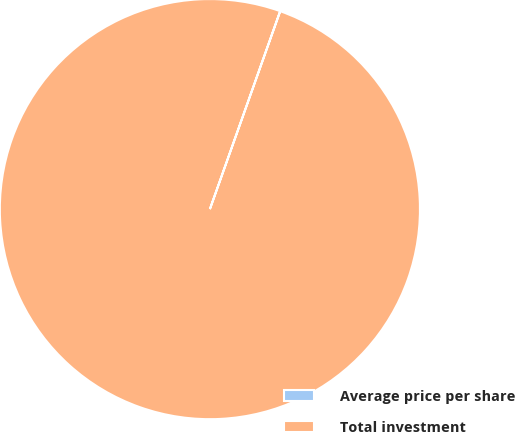<chart> <loc_0><loc_0><loc_500><loc_500><pie_chart><fcel>Average price per share<fcel>Total investment<nl><fcel>0.01%<fcel>99.99%<nl></chart> 